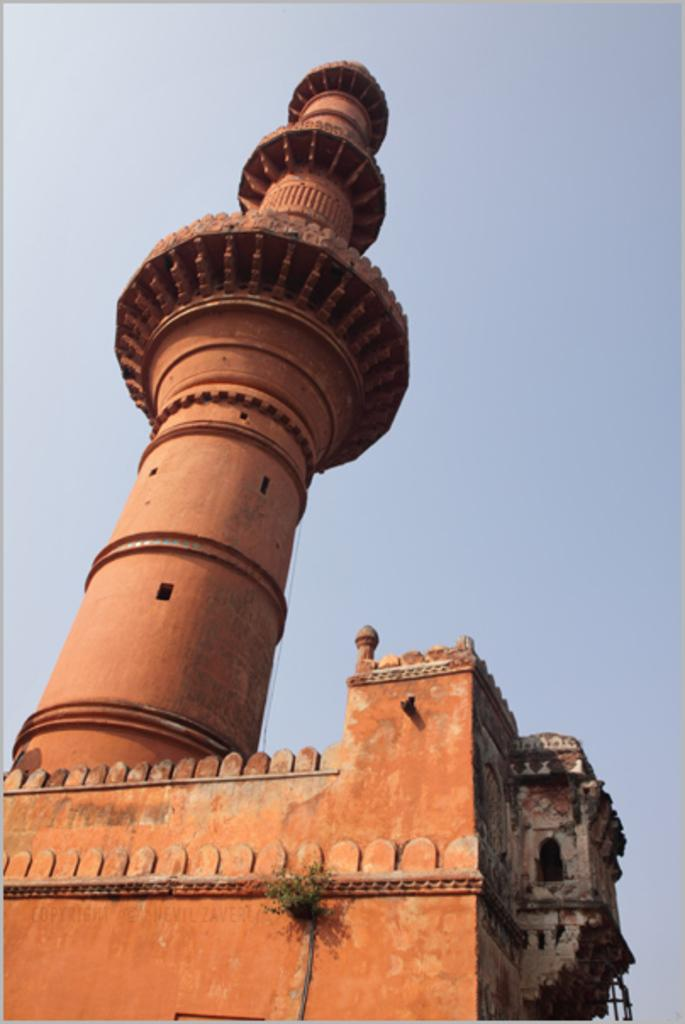What type of structure is depicted in the image? There is a historical construction in the image. What specific feature can be seen on the historical construction? The historical construction has a minaret. What can be seen in the background of the image? There is a sky visible in the background of the image. What type of drug is being sold in the image? There is no indication of any drug being sold or present in the image. 